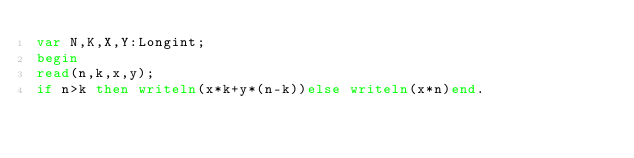Convert code to text. <code><loc_0><loc_0><loc_500><loc_500><_Pascal_>var N,K,X,Y:Longint;
begin
read(n,k,x,y);
if n>k then writeln(x*k+y*(n-k))else writeln(x*n)end.</code> 